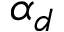<formula> <loc_0><loc_0><loc_500><loc_500>\alpha _ { d }</formula> 